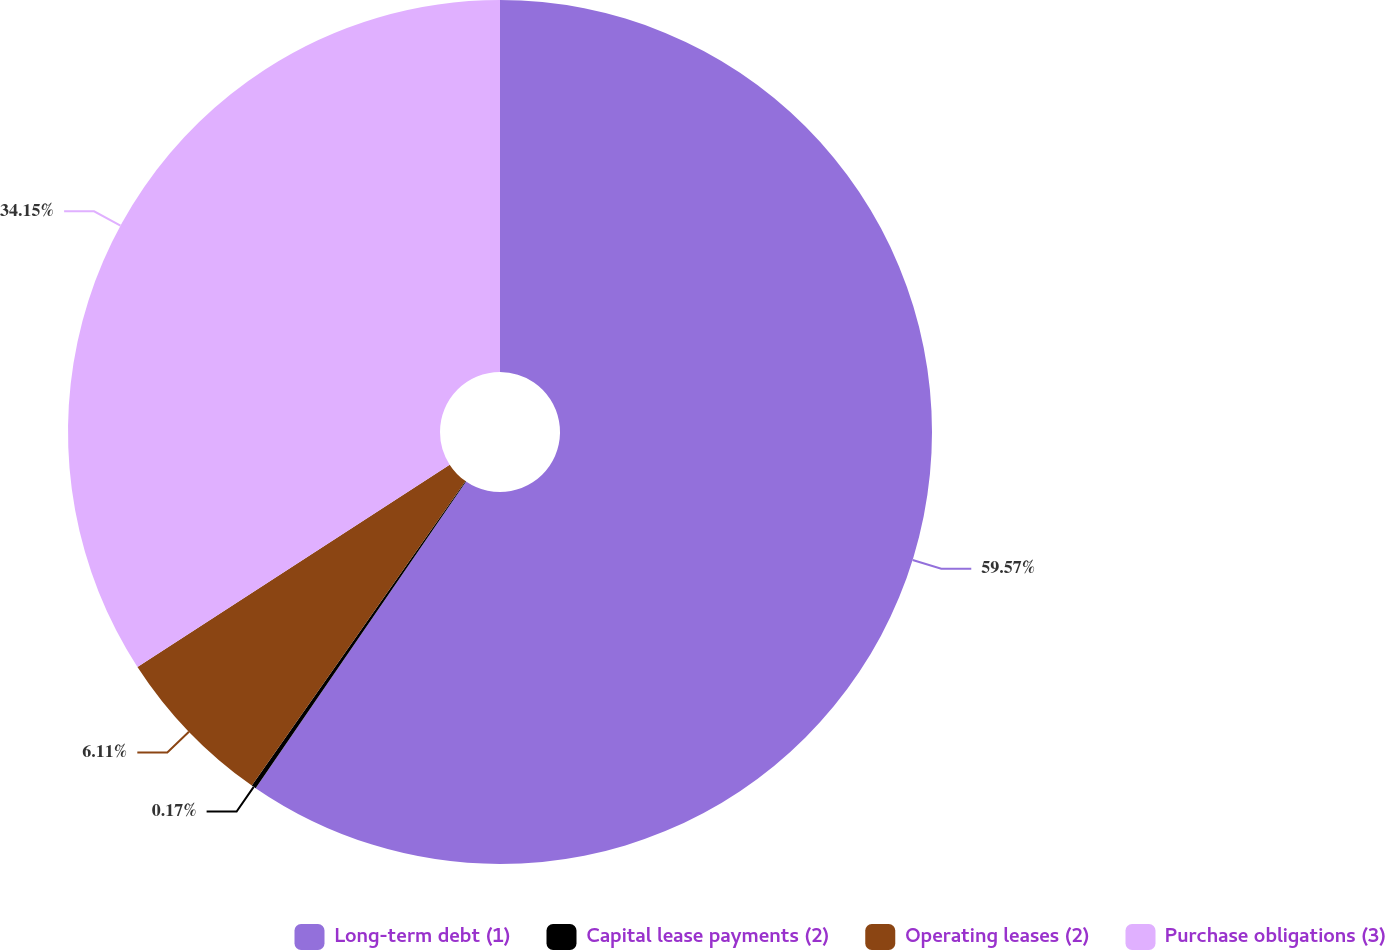<chart> <loc_0><loc_0><loc_500><loc_500><pie_chart><fcel>Long-term debt (1)<fcel>Capital lease payments (2)<fcel>Operating leases (2)<fcel>Purchase obligations (3)<nl><fcel>59.57%<fcel>0.17%<fcel>6.11%<fcel>34.15%<nl></chart> 